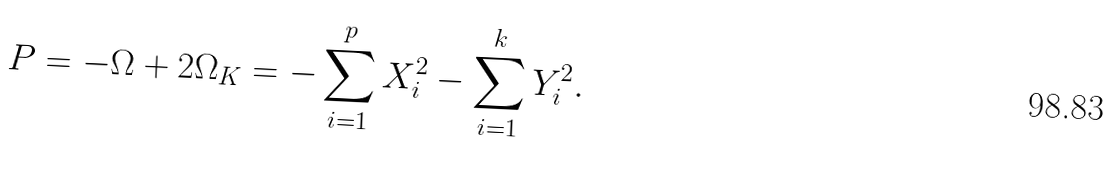Convert formula to latex. <formula><loc_0><loc_0><loc_500><loc_500>P = - \Omega + 2 \Omega _ { K } = - \sum ^ { p } _ { i = 1 } X ^ { 2 } _ { i } - \sum ^ { k } _ { i = 1 } Y ^ { 2 } _ { i } .</formula> 